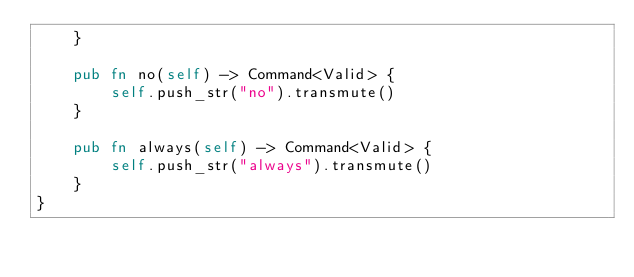Convert code to text. <code><loc_0><loc_0><loc_500><loc_500><_Rust_>    }

    pub fn no(self) -> Command<Valid> {
        self.push_str("no").transmute()
    }

    pub fn always(self) -> Command<Valid> {
        self.push_str("always").transmute()
    }
}
</code> 